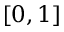Convert formula to latex. <formula><loc_0><loc_0><loc_500><loc_500>[ 0 , 1 ]</formula> 